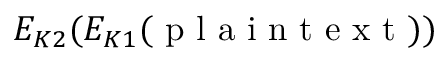<formula> <loc_0><loc_0><loc_500><loc_500>E _ { K 2 } ( E _ { K 1 } ( { p l a i n t e x t } ) )</formula> 